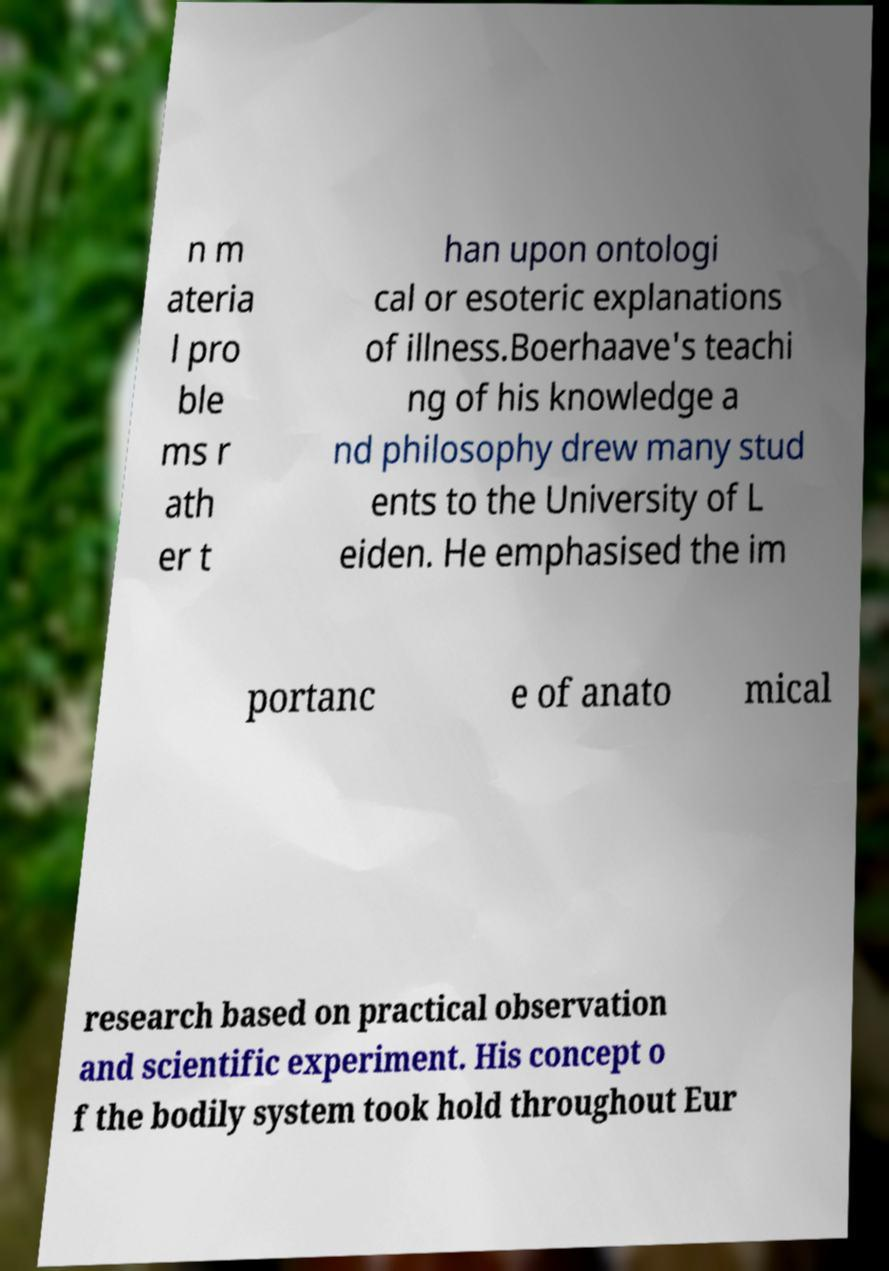Can you accurately transcribe the text from the provided image for me? n m ateria l pro ble ms r ath er t han upon ontologi cal or esoteric explanations of illness.Boerhaave's teachi ng of his knowledge a nd philosophy drew many stud ents to the University of L eiden. He emphasised the im portanc e of anato mical research based on practical observation and scientific experiment. His concept o f the bodily system took hold throughout Eur 